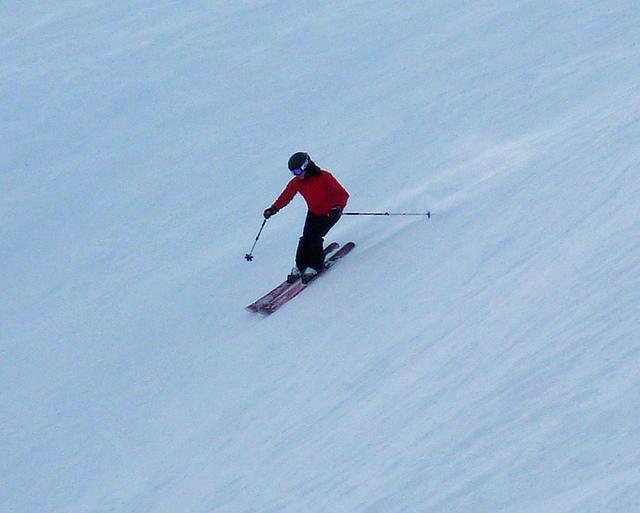How many skiers are there?
Give a very brief answer. 1. 